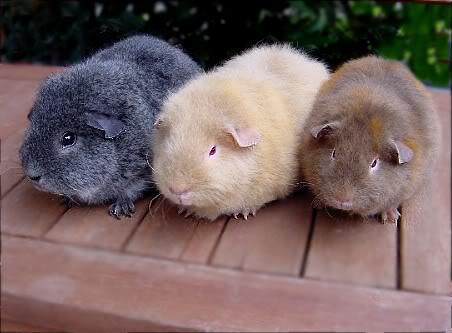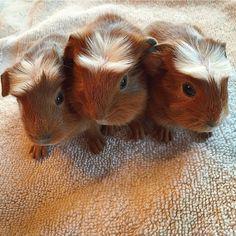The first image is the image on the left, the second image is the image on the right. For the images shown, is this caption "Each image shows exactly three guinea pigs posed tightly together side-by-side." true? Answer yes or no. Yes. The first image is the image on the left, the second image is the image on the right. For the images displayed, is the sentence "There are six mammals huddled in groups of three." factually correct? Answer yes or no. Yes. 